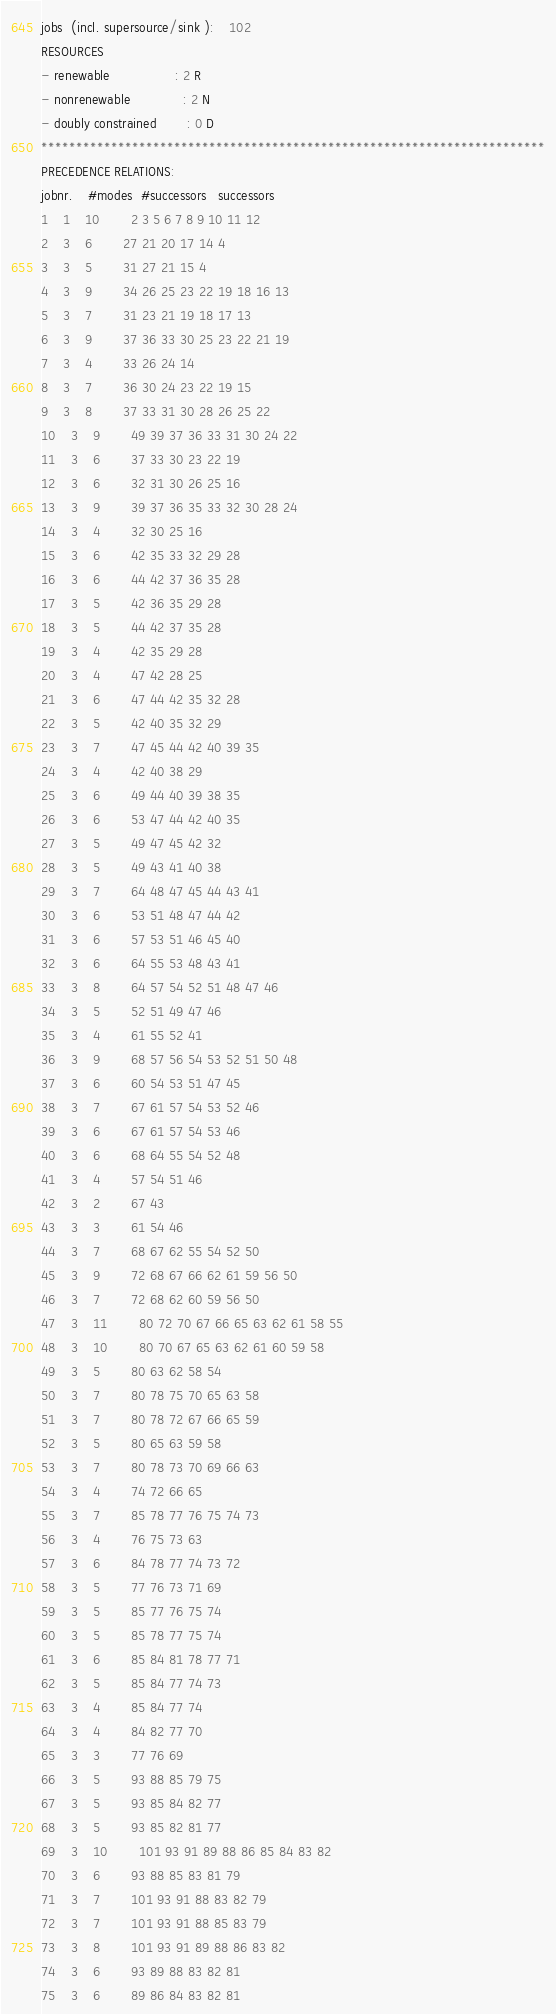Convert code to text. <code><loc_0><loc_0><loc_500><loc_500><_ObjectiveC_>jobs  (incl. supersource/sink ):	102
RESOURCES
- renewable                 : 2 R
- nonrenewable              : 2 N
- doubly constrained        : 0 D
************************************************************************
PRECEDENCE RELATIONS:
jobnr.    #modes  #successors   successors
1	1	10		2 3 5 6 7 8 9 10 11 12 
2	3	6		27 21 20 17 14 4 
3	3	5		31 27 21 15 4 
4	3	9		34 26 25 23 22 19 18 16 13 
5	3	7		31 23 21 19 18 17 13 
6	3	9		37 36 33 30 25 23 22 21 19 
7	3	4		33 26 24 14 
8	3	7		36 30 24 23 22 19 15 
9	3	8		37 33 31 30 28 26 25 22 
10	3	9		49 39 37 36 33 31 30 24 22 
11	3	6		37 33 30 23 22 19 
12	3	6		32 31 30 26 25 16 
13	3	9		39 37 36 35 33 32 30 28 24 
14	3	4		32 30 25 16 
15	3	6		42 35 33 32 29 28 
16	3	6		44 42 37 36 35 28 
17	3	5		42 36 35 29 28 
18	3	5		44 42 37 35 28 
19	3	4		42 35 29 28 
20	3	4		47 42 28 25 
21	3	6		47 44 42 35 32 28 
22	3	5		42 40 35 32 29 
23	3	7		47 45 44 42 40 39 35 
24	3	4		42 40 38 29 
25	3	6		49 44 40 39 38 35 
26	3	6		53 47 44 42 40 35 
27	3	5		49 47 45 42 32 
28	3	5		49 43 41 40 38 
29	3	7		64 48 47 45 44 43 41 
30	3	6		53 51 48 47 44 42 
31	3	6		57 53 51 46 45 40 
32	3	6		64 55 53 48 43 41 
33	3	8		64 57 54 52 51 48 47 46 
34	3	5		52 51 49 47 46 
35	3	4		61 55 52 41 
36	3	9		68 57 56 54 53 52 51 50 48 
37	3	6		60 54 53 51 47 45 
38	3	7		67 61 57 54 53 52 46 
39	3	6		67 61 57 54 53 46 
40	3	6		68 64 55 54 52 48 
41	3	4		57 54 51 46 
42	3	2		67 43 
43	3	3		61 54 46 
44	3	7		68 67 62 55 54 52 50 
45	3	9		72 68 67 66 62 61 59 56 50 
46	3	7		72 68 62 60 59 56 50 
47	3	11		80 72 70 67 66 65 63 62 61 58 55 
48	3	10		80 70 67 65 63 62 61 60 59 58 
49	3	5		80 63 62 58 54 
50	3	7		80 78 75 70 65 63 58 
51	3	7		80 78 72 67 66 65 59 
52	3	5		80 65 63 59 58 
53	3	7		80 78 73 70 69 66 63 
54	3	4		74 72 66 65 
55	3	7		85 78 77 76 75 74 73 
56	3	4		76 75 73 63 
57	3	6		84 78 77 74 73 72 
58	3	5		77 76 73 71 69 
59	3	5		85 77 76 75 74 
60	3	5		85 78 77 75 74 
61	3	6		85 84 81 78 77 71 
62	3	5		85 84 77 74 73 
63	3	4		85 84 77 74 
64	3	4		84 82 77 70 
65	3	3		77 76 69 
66	3	5		93 88 85 79 75 
67	3	5		93 85 84 82 77 
68	3	5		93 85 82 81 77 
69	3	10		101 93 91 89 88 86 85 84 83 82 
70	3	6		93 88 85 83 81 79 
71	3	7		101 93 91 88 83 82 79 
72	3	7		101 93 91 88 85 83 79 
73	3	8		101 93 91 89 88 86 83 82 
74	3	6		93 89 88 83 82 81 
75	3	6		89 86 84 83 82 81 </code> 